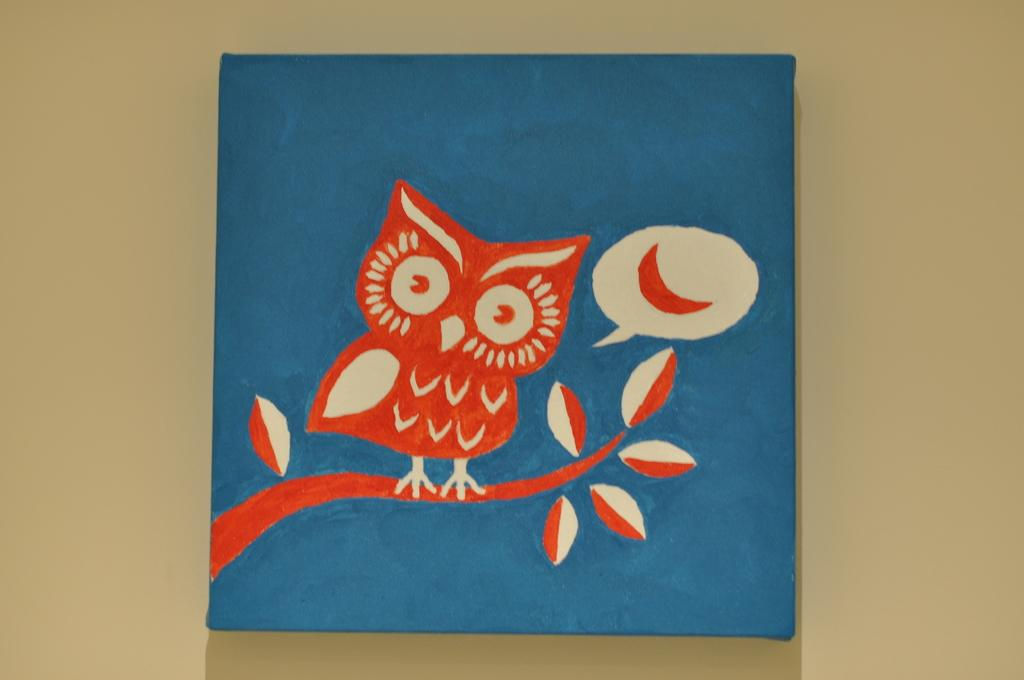What is the main subject of the image? There is a wall painting in the image. Can you describe the setting of the image? The image might have been taken in a room. What nation is depicted in the wall painting? There is no specific nation depicted in the wall painting, as it is not mentioned in the facts provided. 